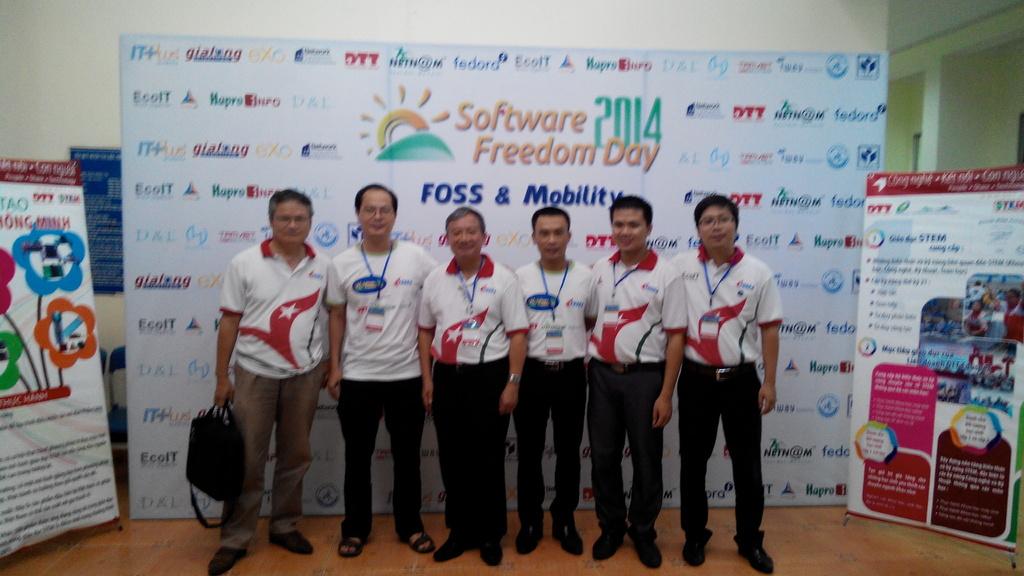What year was the photo taken?
Offer a terse response. 2014. Is this for freedom day?
Your answer should be very brief. Yes. 